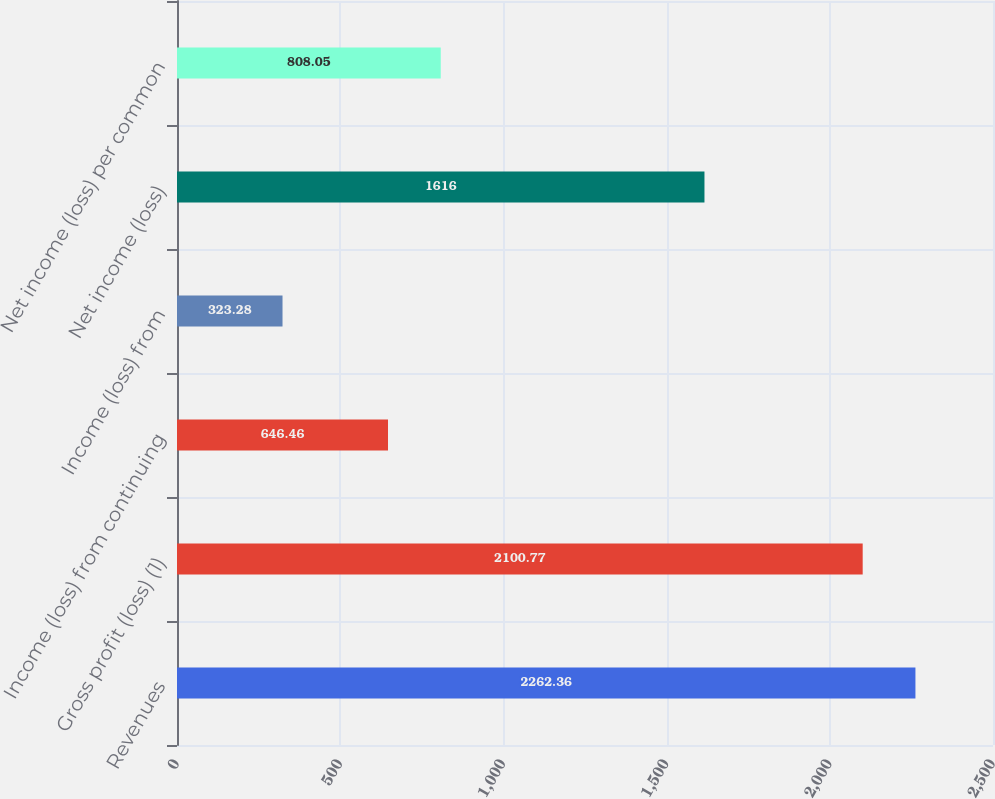<chart> <loc_0><loc_0><loc_500><loc_500><bar_chart><fcel>Revenues<fcel>Gross profit (loss) (1)<fcel>Income (loss) from continuing<fcel>Income (loss) from<fcel>Net income (loss)<fcel>Net income (loss) per common<nl><fcel>2262.36<fcel>2100.77<fcel>646.46<fcel>323.28<fcel>1616<fcel>808.05<nl></chart> 